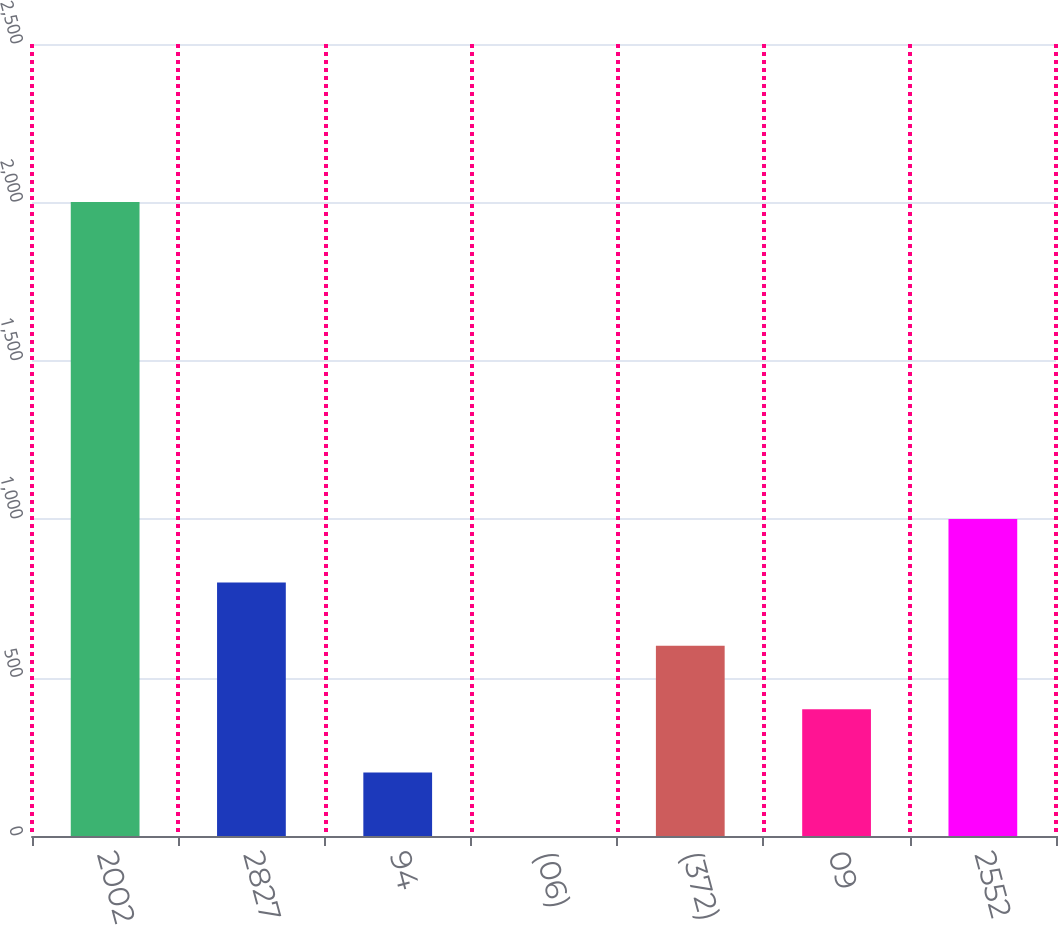Convert chart. <chart><loc_0><loc_0><loc_500><loc_500><bar_chart><fcel>2002<fcel>2827<fcel>94<fcel>(06)<fcel>(372)<fcel>09<fcel>2552<nl><fcel>2001<fcel>800.52<fcel>200.28<fcel>0.2<fcel>600.44<fcel>400.36<fcel>1000.6<nl></chart> 